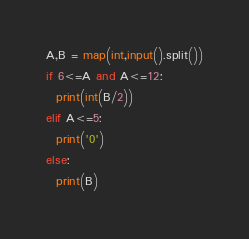<code> <loc_0><loc_0><loc_500><loc_500><_Python_>A,B = map(int,input().split())
if 6<=A and A<=12:
  print(int(B/2))
elif A<=5:
  print('0')
else:
  print(B)</code> 